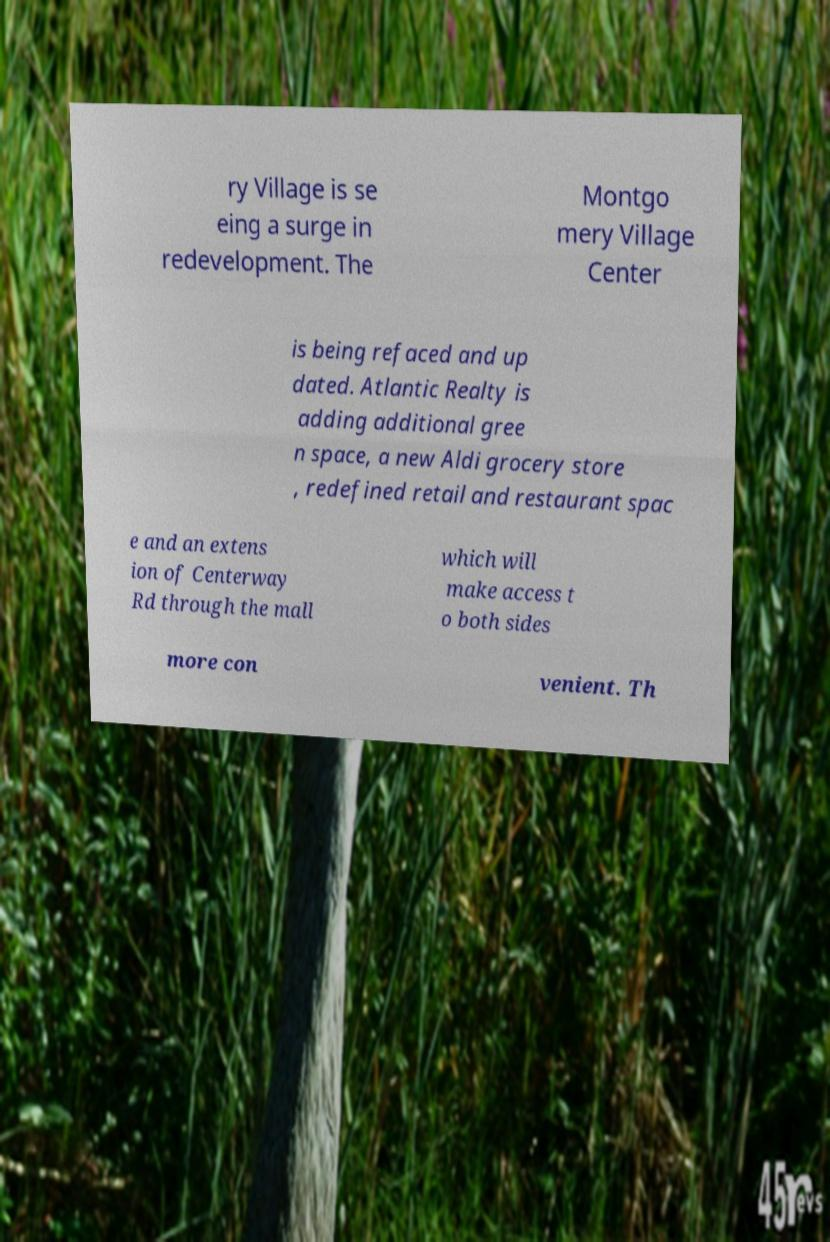Please read and relay the text visible in this image. What does it say? ry Village is se eing a surge in redevelopment. The Montgo mery Village Center is being refaced and up dated. Atlantic Realty is adding additional gree n space, a new Aldi grocery store , redefined retail and restaurant spac e and an extens ion of Centerway Rd through the mall which will make access t o both sides more con venient. Th 